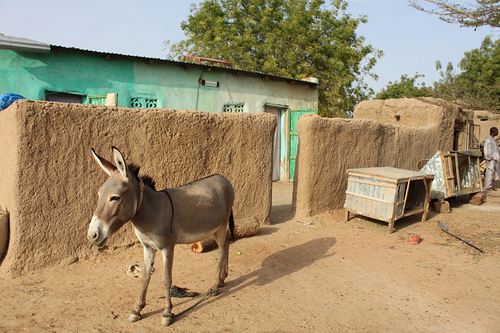<image>
Can you confirm if the donkey is in front of the log? Yes. The donkey is positioned in front of the log, appearing closer to the camera viewpoint. 